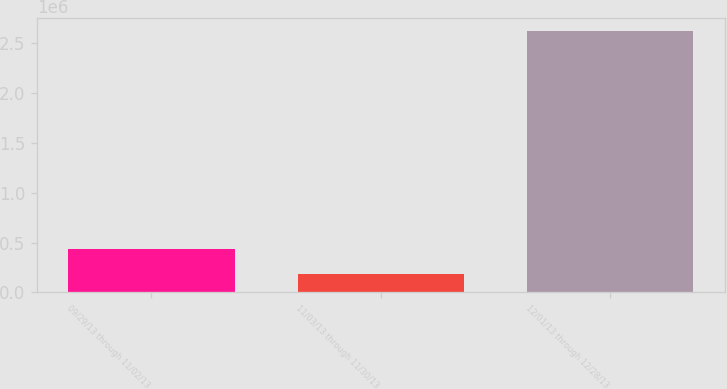Convert chart. <chart><loc_0><loc_0><loc_500><loc_500><bar_chart><fcel>09/29/13 through 11/02/13<fcel>11/03/13 through 11/30/13<fcel>12/01/13 through 12/28/13<nl><fcel>433702<fcel>182662<fcel>2.6205e+06<nl></chart> 